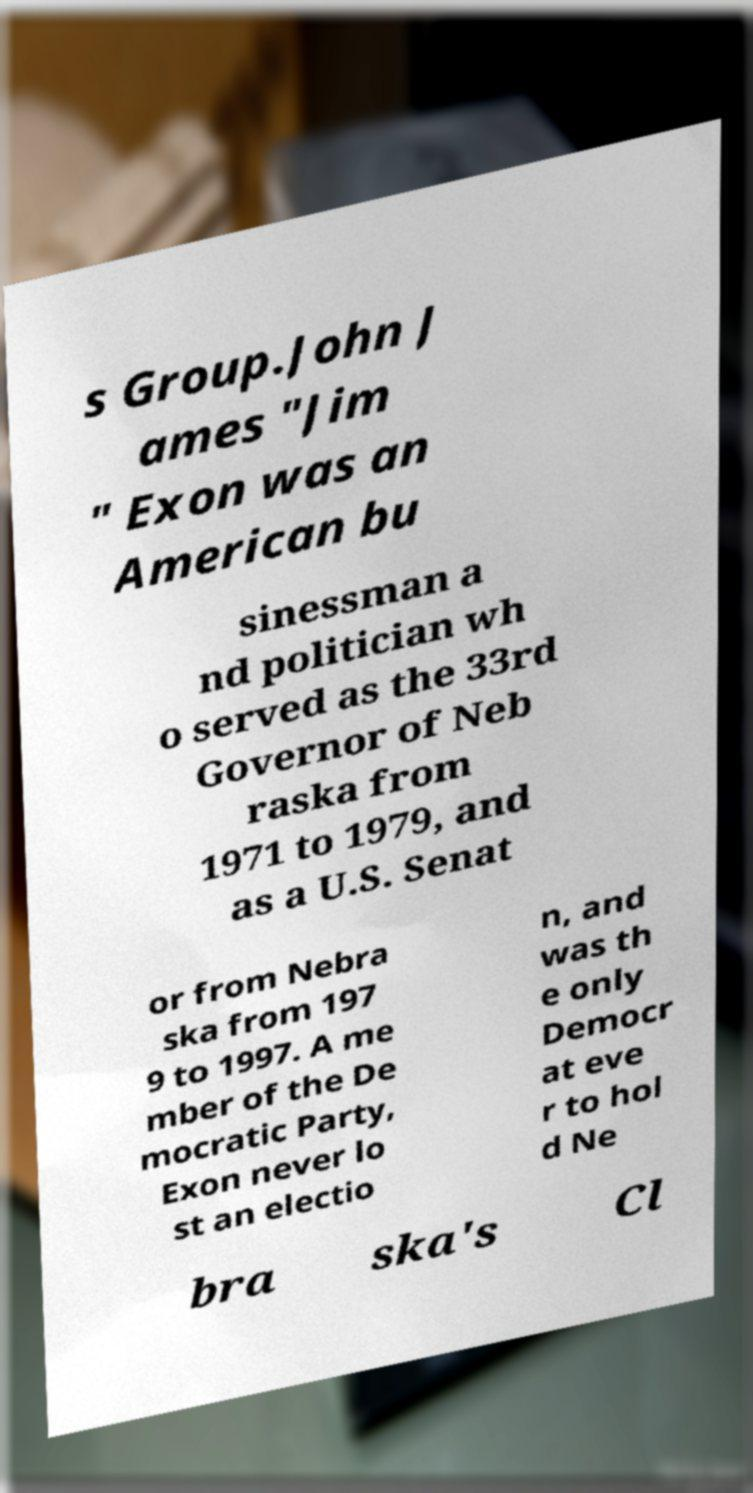There's text embedded in this image that I need extracted. Can you transcribe it verbatim? s Group.John J ames "Jim " Exon was an American bu sinessman a nd politician wh o served as the 33rd Governor of Neb raska from 1971 to 1979, and as a U.S. Senat or from Nebra ska from 197 9 to 1997. A me mber of the De mocratic Party, Exon never lo st an electio n, and was th e only Democr at eve r to hol d Ne bra ska's Cl 